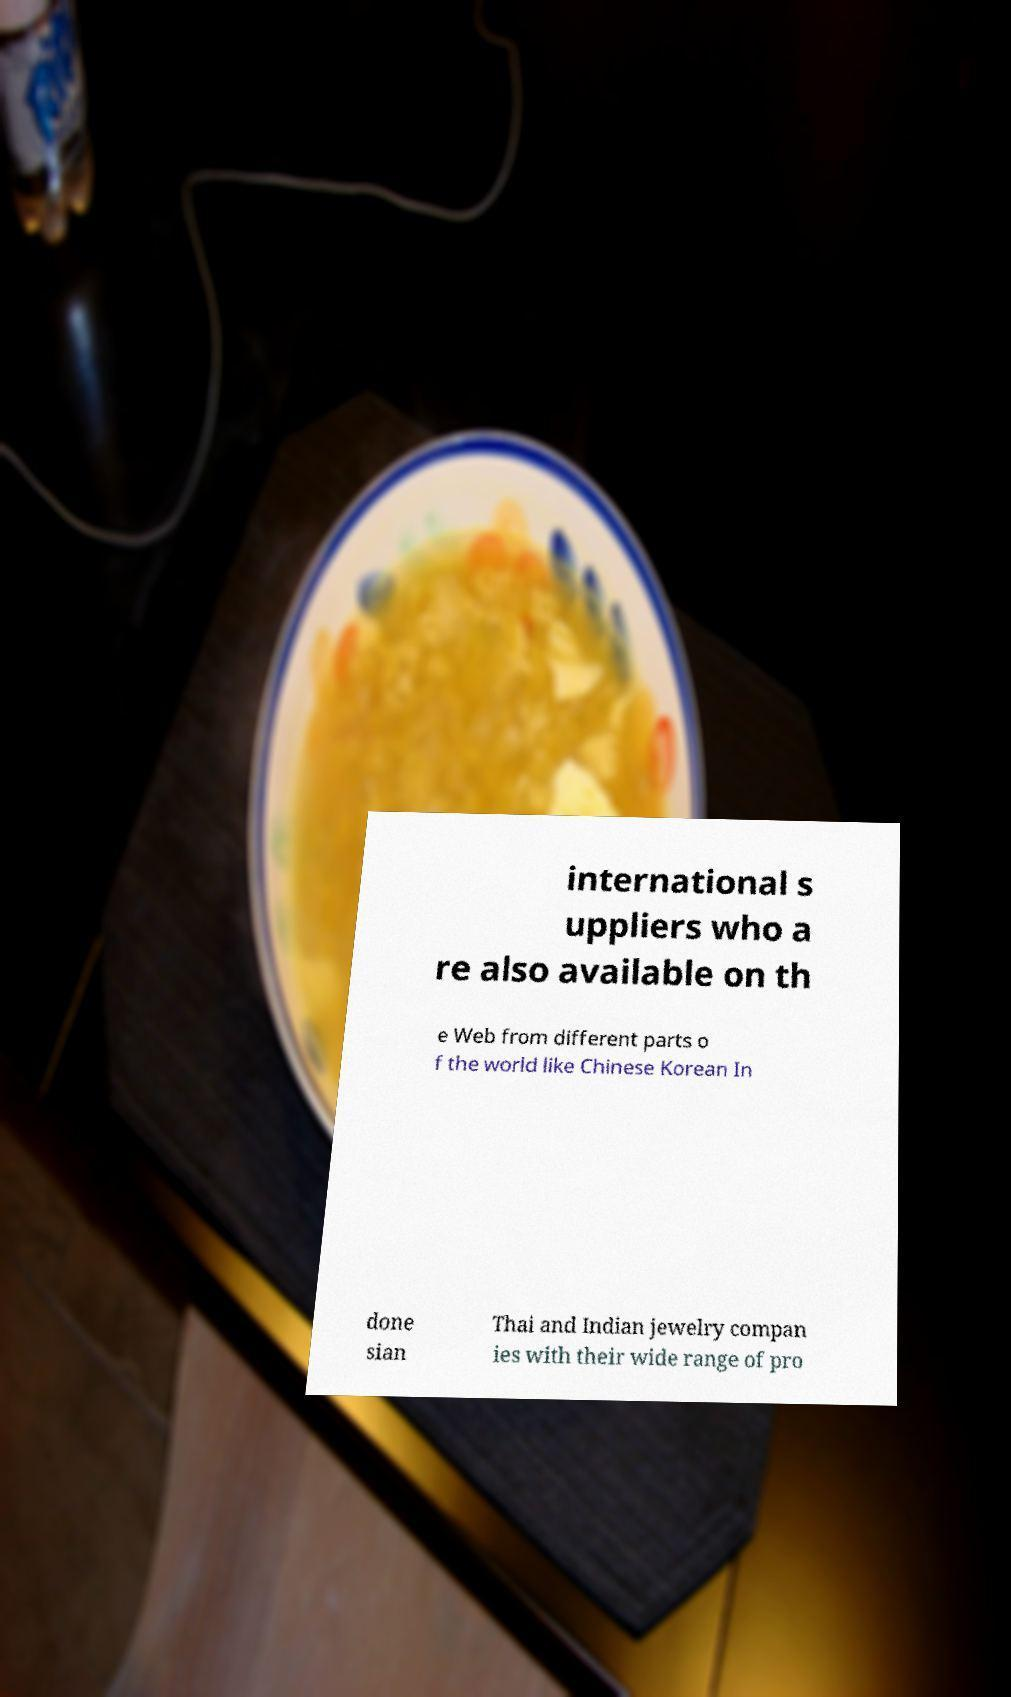Can you accurately transcribe the text from the provided image for me? international s uppliers who a re also available on th e Web from different parts o f the world like Chinese Korean In done sian Thai and Indian jewelry compan ies with their wide range of pro 